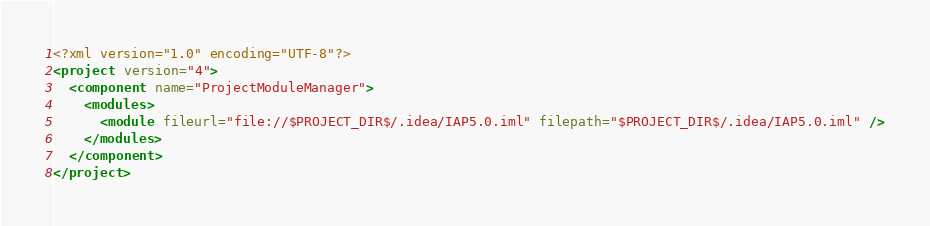<code> <loc_0><loc_0><loc_500><loc_500><_XML_><?xml version="1.0" encoding="UTF-8"?>
<project version="4">
  <component name="ProjectModuleManager">
    <modules>
      <module fileurl="file://$PROJECT_DIR$/.idea/IAP5.0.iml" filepath="$PROJECT_DIR$/.idea/IAP5.0.iml" />
    </modules>
  </component>
</project></code> 